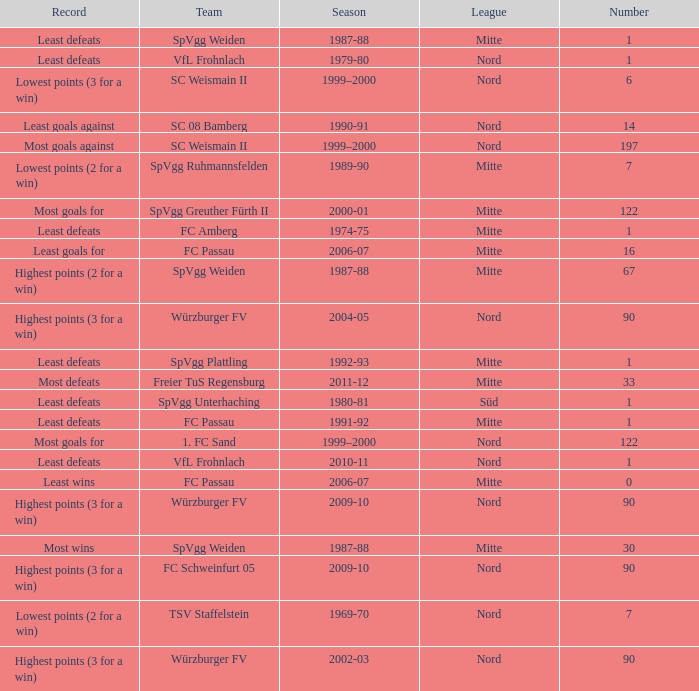What league has a number less than 1? Mitte. 